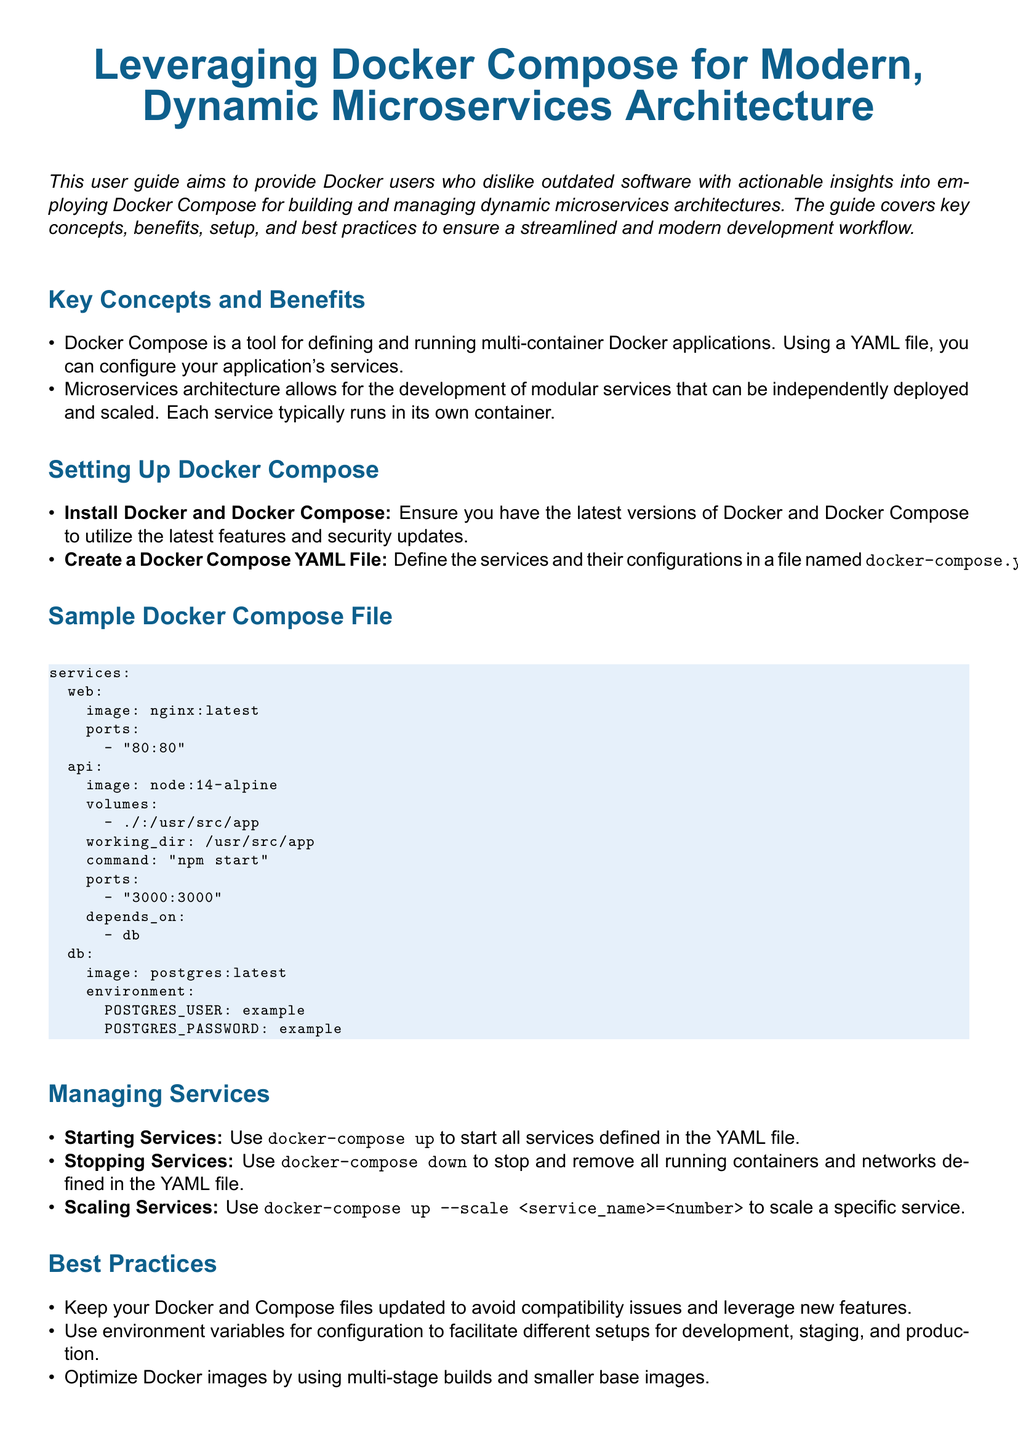What is the main purpose of the user guide? The user guide aims to provide actionable insights for Docker users on employing Docker Compose for modern microservices architectures.
Answer: actionable insights for Docker users What is the command to start all services defined in the YAML file? The command to start all services is highlighted in the document as part of the managing services section.
Answer: docker-compose up Which service uses nginx as an image? This question relates to the sample Docker Compose file where images for various services are defined.
Answer: web How can you scale a specific service? The scaling method is described in the managing services section; it requires specific command syntax.
Answer: docker-compose up --scale <service_name>=<number> What type of architecture does Docker Compose support according to the guide? The user guide mentions the architecture that allows for modular service development and deployment.
Answer: microservices architecture What should be monitored and secured using specific tools according to the best practices? The document mentions a recommendation for monitoring and securing components of the architecture.
Answer: containers What is the recommended database image in the sample file? This refers to the 'db' service as defined in the sample Docker Compose file.
Answer: postgres:latest Which environment variable is recommended for configuration? The best practices section suggests using a specific type of variable for easier setup transitions.
Answer: environment variables What is the latest Docker version mentioned for installation? The setup instructions specify this in the context of ensuring feature and security updates.
Answer: latest versions 